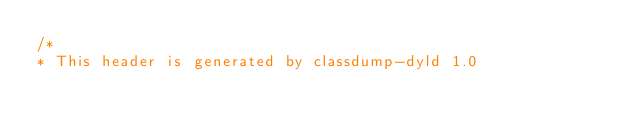<code> <loc_0><loc_0><loc_500><loc_500><_C_>/*
* This header is generated by classdump-dyld 1.0</code> 